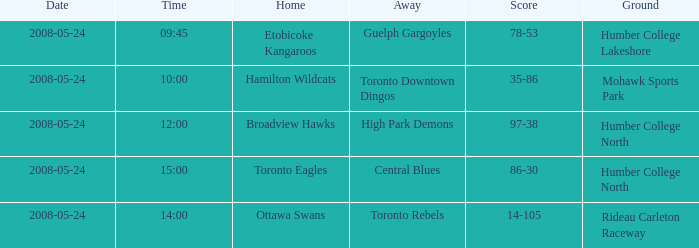Who was the home team of the game at the time of 15:00? Toronto Eagles. 